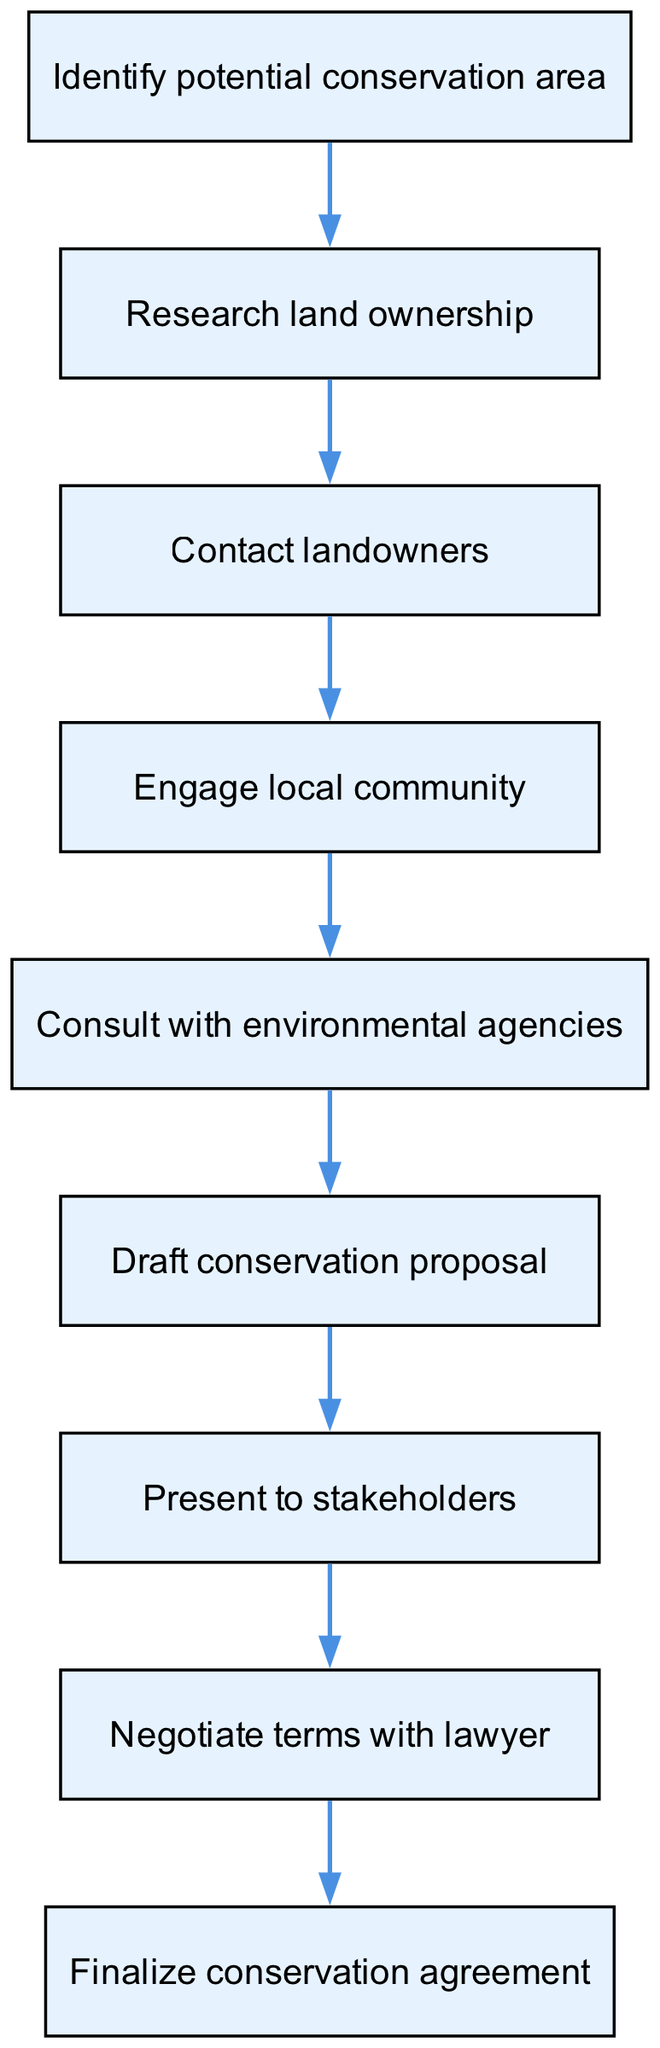What is the first step in the conservation area designation process? The first step in the flow chart is indicated by the first node, which is "Identify potential conservation area." This represents the initial action that initiates the process of conservation area designation.
Answer: Identify potential conservation area How many nodes are present in the diagram? To find the number of nodes, we can count each distinct step listed in the "nodes" section. There are 9 nodes in total, each representing a different step in the process.
Answer: 9 What step follows "Consult with environmental agencies"? In the flow of the diagram, the node that follows "Consult with environmental agencies" is "Draft conservation proposal," indicating the next action after consulting agencies.
Answer: Draft conservation proposal Which step involves communication with landowners? The step that involves communication with landowners is "Contact landowners." This is depicted as a direct link in the flow chart after researching land ownership.
Answer: Contact landowners What is the last step in the sequence? The last step in the flow chart is "Finalize conservation agreement." It is positioned at the end of the flow diagram, signifying the conclusion of the process.
Answer: Finalize conservation agreement What nodes are connected directly to "Engage local community"? The node "Engage local community" connects directly to "Contact landowners" before it and "Consult with environmental agencies" after it, showing the flow of engagement in the process.
Answer: Contact landowners, Consult with environmental agencies How many edges connect the nodes in the diagram? To determine the number of edges, we can count the connections between nodes as outlined in the "edges" section of the diagram. There are 8 edges that connect the 9 nodes.
Answer: 8 Which step is most closely related to the legal aspect of conservation? The step that most closely relates to the legal aspect of conservation is "Negotiate terms with lawyer." This indicates the involvement of legal professionals in the conservation agreement process.
Answer: Negotiate terms with lawyer 